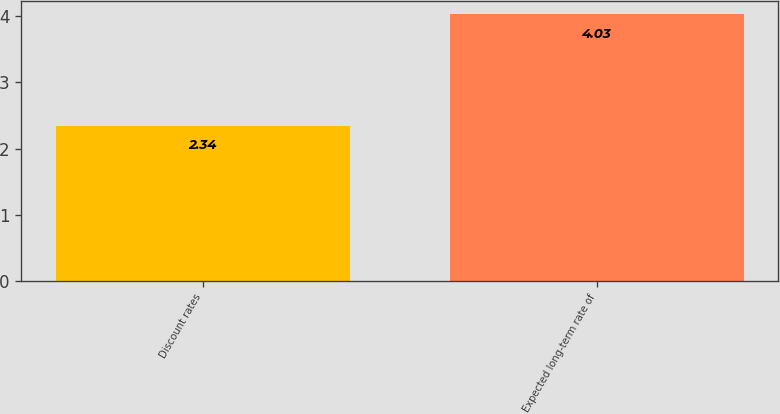<chart> <loc_0><loc_0><loc_500><loc_500><bar_chart><fcel>Discount rates<fcel>Expected long-term rate of<nl><fcel>2.34<fcel>4.03<nl></chart> 